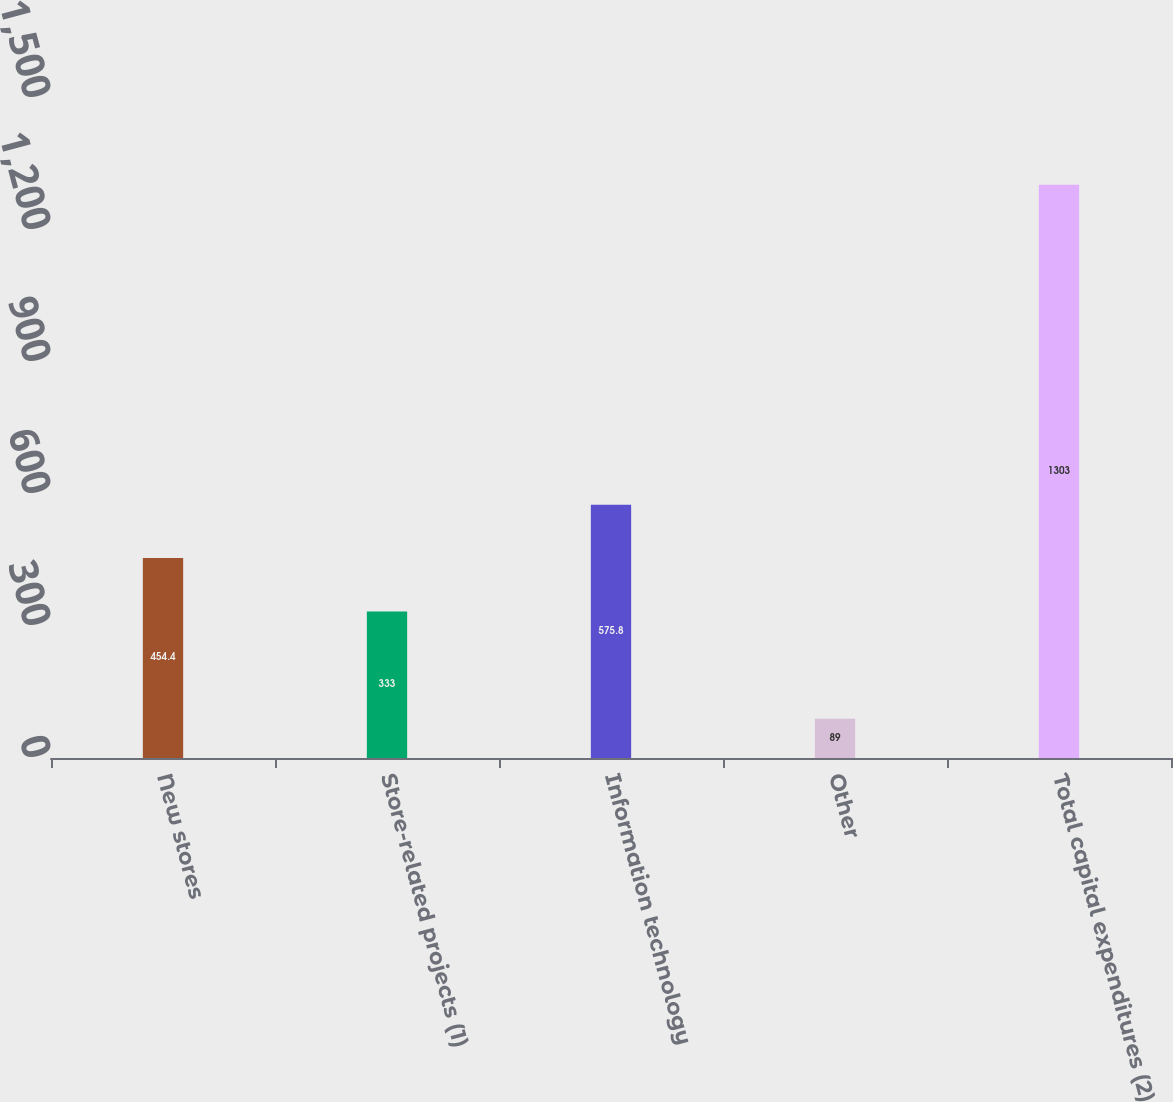Convert chart. <chart><loc_0><loc_0><loc_500><loc_500><bar_chart><fcel>New stores<fcel>Store-related projects (1)<fcel>Information technology<fcel>Other<fcel>Total capital expenditures (2)<nl><fcel>454.4<fcel>333<fcel>575.8<fcel>89<fcel>1303<nl></chart> 